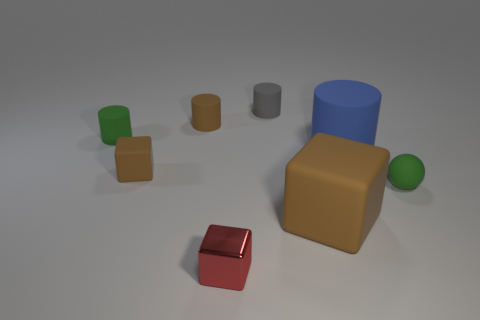Is there a small metal thing that has the same color as the large rubber cube?
Offer a very short reply. No. What size is the green ball that is the same material as the small gray cylinder?
Provide a short and direct response. Small. Are the gray cylinder and the blue cylinder made of the same material?
Your answer should be very brief. Yes. What is the color of the rubber cylinder that is in front of the matte cylinder that is on the left side of the tiny brown thing behind the small green rubber cylinder?
Make the answer very short. Blue. What is the shape of the small red thing?
Give a very brief answer. Cube. There is a big cylinder; does it have the same color as the block on the right side of the gray rubber cylinder?
Provide a succinct answer. No. Is the number of small rubber cylinders that are behind the small green cylinder the same as the number of small brown matte cylinders?
Make the answer very short. No. How many red metallic blocks are the same size as the ball?
Ensure brevity in your answer.  1. The tiny object that is the same color as the tiny rubber block is what shape?
Your answer should be compact. Cylinder. Is there a big gray ball?
Offer a terse response. No. 